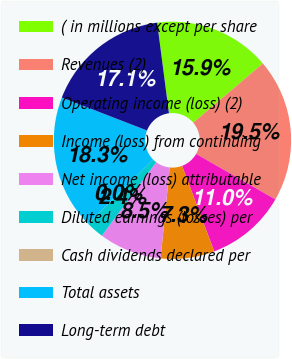Convert chart to OTSL. <chart><loc_0><loc_0><loc_500><loc_500><pie_chart><fcel>( in millions except per share<fcel>Revenues (2)<fcel>Operating income (loss) (2)<fcel>Income (loss) from continuing<fcel>Net income (loss) attributable<fcel>Diluted earnings (losses) per<fcel>Cash dividends declared per<fcel>Total assets<fcel>Long-term debt<nl><fcel>15.85%<fcel>19.51%<fcel>10.98%<fcel>7.32%<fcel>8.54%<fcel>2.44%<fcel>0.0%<fcel>18.29%<fcel>17.07%<nl></chart> 